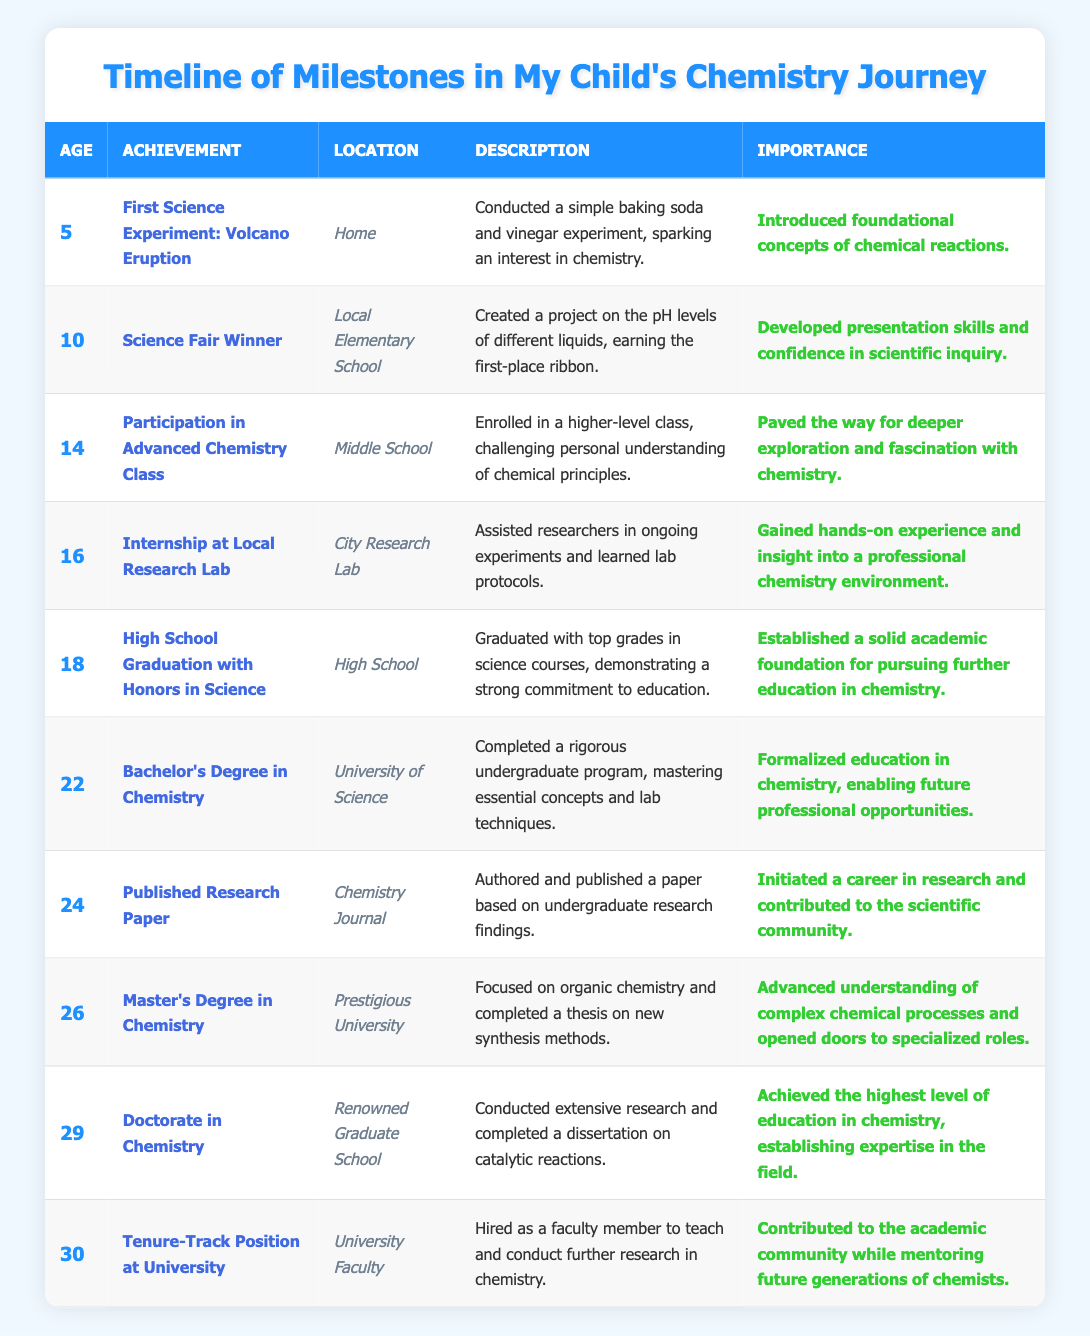What achievement did the chemist accomplish at age 10? According to the table, at age 10, the chemist won first place at the science fair with a project on pH levels of different liquids.
Answer: Science Fair Winner How many years passed between the chemist's high school graduation and obtaining a bachelor’s degree? The chemist graduated high school at age 18 and obtained a bachelor’s degree at age 22. The difference is 22 - 18 = 4 years.
Answer: 4 years True or False: The chemist published a research paper before completing their master’s degree. The table shows that the chemist published a research paper at age 24 and completed a master’s degree at age 26. Thus, the statement is true as they published the paper before completing the degree.
Answer: True What age did the chemist start the first science-related activity? The first science activity cited was the volcano eruption experiment at age 5, as detailed in the table.
Answer: Age 5 Calculate the total number of years from the first science experiment to obtaining a doctorate degree. The chemist's first experiment was at age 5, and they received their doctorate at age 29. So, the total years from 5 to 29 is 29 - 5 = 24 years.
Answer: 24 years What was the location of the chemist's internship? The internship took place at the City Research Lab, as specified in the timeline.
Answer: City Research Lab How many achievements did the chemist accomplish by age 24? The milestones up to age 24 include 1 (age 5), 2 (age 10), 3 (age 14), 4 (age 16), 5 (age 18), 6 (age 22), and 7 (age 24), totaling 7 achievements by that age.
Answer: 7 achievements Which achievement was associated with the location of "University Faculty"? The relevant achievement at "University Faculty" is the tenure-track position at age 30, as listed in the table.
Answer: Tenure-Track Position at University Did the chemist's early experiments lead to a scholarship for higher education? The early experiments, such as the first science experiment and winning the science fair, contributed to building foundational skills but did not directly mention a scholarship. However, high school graduation with honors likely supported higher education pursuits. Thus, there's no direct answer from the data for a scholarship.
Answer: Cannot be determined What are the two highest degrees the chemist obtained? According to the table, the two highest degrees are a Master’s Degree in Chemistry at age 26 and a Doctorate in Chemistry at age 29.
Answer: Master’s and Doctorate Degrees 